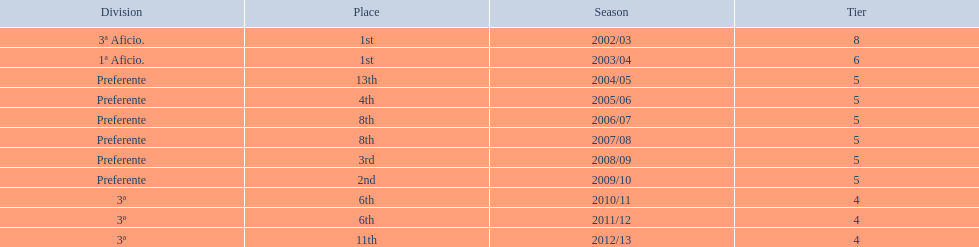What place did the team place in 2010/11? 6th. In what other year did they place 6th? 2011/12. 